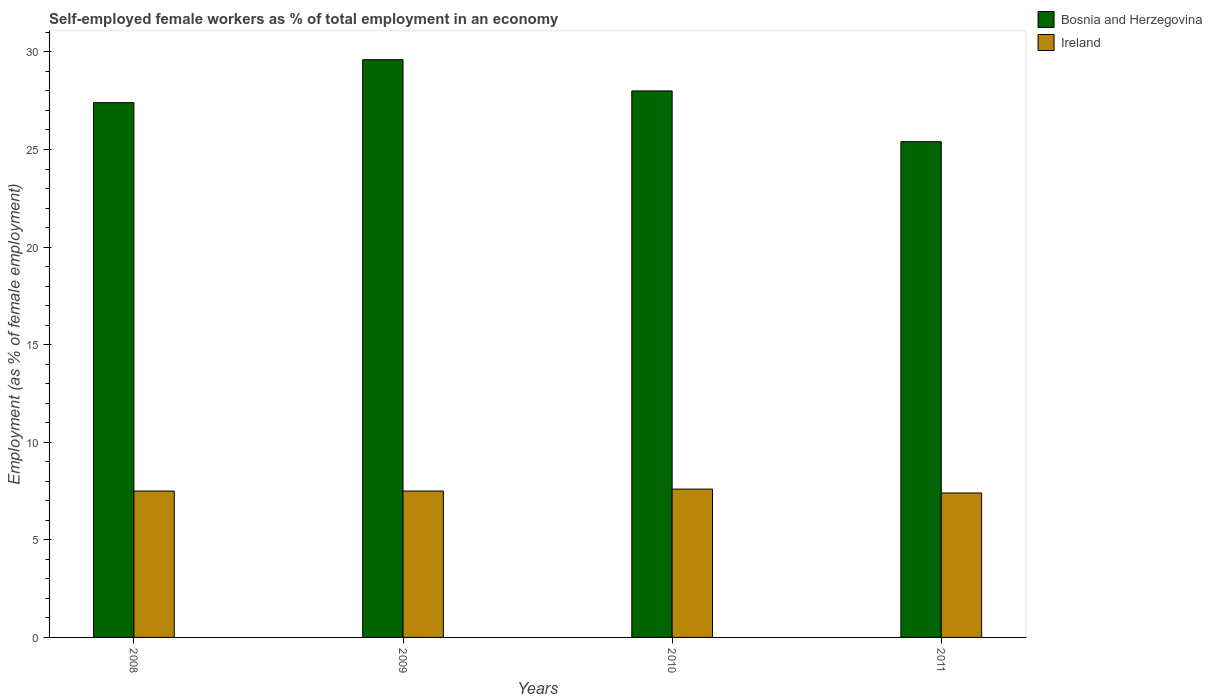How many different coloured bars are there?
Ensure brevity in your answer.  2. How many groups of bars are there?
Ensure brevity in your answer.  4. Are the number of bars per tick equal to the number of legend labels?
Provide a short and direct response. Yes. Are the number of bars on each tick of the X-axis equal?
Keep it short and to the point. Yes. How many bars are there on the 3rd tick from the left?
Offer a terse response. 2. In how many cases, is the number of bars for a given year not equal to the number of legend labels?
Ensure brevity in your answer.  0. What is the percentage of self-employed female workers in Ireland in 2009?
Make the answer very short. 7.5. Across all years, what is the maximum percentage of self-employed female workers in Ireland?
Give a very brief answer. 7.6. Across all years, what is the minimum percentage of self-employed female workers in Ireland?
Keep it short and to the point. 7.4. In which year was the percentage of self-employed female workers in Ireland minimum?
Give a very brief answer. 2011. What is the total percentage of self-employed female workers in Bosnia and Herzegovina in the graph?
Keep it short and to the point. 110.4. What is the difference between the percentage of self-employed female workers in Ireland in 2010 and that in 2011?
Ensure brevity in your answer.  0.2. What is the difference between the percentage of self-employed female workers in Bosnia and Herzegovina in 2008 and the percentage of self-employed female workers in Ireland in 2011?
Provide a short and direct response. 20. What is the average percentage of self-employed female workers in Ireland per year?
Provide a succinct answer. 7.5. In the year 2010, what is the difference between the percentage of self-employed female workers in Ireland and percentage of self-employed female workers in Bosnia and Herzegovina?
Make the answer very short. -20.4. In how many years, is the percentage of self-employed female workers in Bosnia and Herzegovina greater than 16 %?
Your answer should be compact. 4. What is the ratio of the percentage of self-employed female workers in Ireland in 2010 to that in 2011?
Make the answer very short. 1.03. Is the percentage of self-employed female workers in Bosnia and Herzegovina in 2008 less than that in 2011?
Offer a very short reply. No. What is the difference between the highest and the second highest percentage of self-employed female workers in Bosnia and Herzegovina?
Provide a succinct answer. 1.6. What is the difference between the highest and the lowest percentage of self-employed female workers in Bosnia and Herzegovina?
Ensure brevity in your answer.  4.2. Is the sum of the percentage of self-employed female workers in Ireland in 2008 and 2010 greater than the maximum percentage of self-employed female workers in Bosnia and Herzegovina across all years?
Provide a short and direct response. No. What does the 2nd bar from the left in 2011 represents?
Keep it short and to the point. Ireland. What does the 2nd bar from the right in 2008 represents?
Ensure brevity in your answer.  Bosnia and Herzegovina. Are all the bars in the graph horizontal?
Provide a succinct answer. No. How many years are there in the graph?
Offer a very short reply. 4. Does the graph contain any zero values?
Your answer should be compact. No. Where does the legend appear in the graph?
Your response must be concise. Top right. What is the title of the graph?
Provide a short and direct response. Self-employed female workers as % of total employment in an economy. What is the label or title of the Y-axis?
Provide a short and direct response. Employment (as % of female employment). What is the Employment (as % of female employment) in Bosnia and Herzegovina in 2008?
Keep it short and to the point. 27.4. What is the Employment (as % of female employment) in Ireland in 2008?
Offer a very short reply. 7.5. What is the Employment (as % of female employment) in Bosnia and Herzegovina in 2009?
Provide a succinct answer. 29.6. What is the Employment (as % of female employment) of Ireland in 2009?
Provide a short and direct response. 7.5. What is the Employment (as % of female employment) of Ireland in 2010?
Provide a succinct answer. 7.6. What is the Employment (as % of female employment) in Bosnia and Herzegovina in 2011?
Provide a succinct answer. 25.4. What is the Employment (as % of female employment) of Ireland in 2011?
Make the answer very short. 7.4. Across all years, what is the maximum Employment (as % of female employment) in Bosnia and Herzegovina?
Offer a terse response. 29.6. Across all years, what is the maximum Employment (as % of female employment) in Ireland?
Give a very brief answer. 7.6. Across all years, what is the minimum Employment (as % of female employment) in Bosnia and Herzegovina?
Ensure brevity in your answer.  25.4. Across all years, what is the minimum Employment (as % of female employment) of Ireland?
Give a very brief answer. 7.4. What is the total Employment (as % of female employment) in Bosnia and Herzegovina in the graph?
Your response must be concise. 110.4. What is the total Employment (as % of female employment) of Ireland in the graph?
Offer a terse response. 30. What is the difference between the Employment (as % of female employment) of Bosnia and Herzegovina in 2008 and that in 2009?
Your answer should be compact. -2.2. What is the difference between the Employment (as % of female employment) in Ireland in 2008 and that in 2009?
Provide a short and direct response. 0. What is the difference between the Employment (as % of female employment) of Bosnia and Herzegovina in 2008 and that in 2010?
Ensure brevity in your answer.  -0.6. What is the difference between the Employment (as % of female employment) in Ireland in 2008 and that in 2010?
Your answer should be compact. -0.1. What is the difference between the Employment (as % of female employment) of Bosnia and Herzegovina in 2008 and that in 2011?
Ensure brevity in your answer.  2. What is the difference between the Employment (as % of female employment) in Bosnia and Herzegovina in 2009 and that in 2010?
Your answer should be compact. 1.6. What is the difference between the Employment (as % of female employment) in Bosnia and Herzegovina in 2009 and that in 2011?
Your answer should be very brief. 4.2. What is the difference between the Employment (as % of female employment) of Bosnia and Herzegovina in 2010 and that in 2011?
Your response must be concise. 2.6. What is the difference between the Employment (as % of female employment) of Ireland in 2010 and that in 2011?
Provide a succinct answer. 0.2. What is the difference between the Employment (as % of female employment) of Bosnia and Herzegovina in 2008 and the Employment (as % of female employment) of Ireland in 2010?
Keep it short and to the point. 19.8. What is the difference between the Employment (as % of female employment) in Bosnia and Herzegovina in 2008 and the Employment (as % of female employment) in Ireland in 2011?
Provide a short and direct response. 20. What is the difference between the Employment (as % of female employment) in Bosnia and Herzegovina in 2009 and the Employment (as % of female employment) in Ireland in 2011?
Offer a terse response. 22.2. What is the difference between the Employment (as % of female employment) of Bosnia and Herzegovina in 2010 and the Employment (as % of female employment) of Ireland in 2011?
Ensure brevity in your answer.  20.6. What is the average Employment (as % of female employment) in Bosnia and Herzegovina per year?
Give a very brief answer. 27.6. What is the average Employment (as % of female employment) in Ireland per year?
Give a very brief answer. 7.5. In the year 2008, what is the difference between the Employment (as % of female employment) in Bosnia and Herzegovina and Employment (as % of female employment) in Ireland?
Your answer should be compact. 19.9. In the year 2009, what is the difference between the Employment (as % of female employment) of Bosnia and Herzegovina and Employment (as % of female employment) of Ireland?
Make the answer very short. 22.1. In the year 2010, what is the difference between the Employment (as % of female employment) of Bosnia and Herzegovina and Employment (as % of female employment) of Ireland?
Keep it short and to the point. 20.4. What is the ratio of the Employment (as % of female employment) in Bosnia and Herzegovina in 2008 to that in 2009?
Keep it short and to the point. 0.93. What is the ratio of the Employment (as % of female employment) in Bosnia and Herzegovina in 2008 to that in 2010?
Ensure brevity in your answer.  0.98. What is the ratio of the Employment (as % of female employment) of Bosnia and Herzegovina in 2008 to that in 2011?
Offer a terse response. 1.08. What is the ratio of the Employment (as % of female employment) in Ireland in 2008 to that in 2011?
Provide a succinct answer. 1.01. What is the ratio of the Employment (as % of female employment) in Bosnia and Herzegovina in 2009 to that in 2010?
Make the answer very short. 1.06. What is the ratio of the Employment (as % of female employment) in Bosnia and Herzegovina in 2009 to that in 2011?
Give a very brief answer. 1.17. What is the ratio of the Employment (as % of female employment) in Ireland in 2009 to that in 2011?
Provide a short and direct response. 1.01. What is the ratio of the Employment (as % of female employment) of Bosnia and Herzegovina in 2010 to that in 2011?
Your answer should be very brief. 1.1. What is the ratio of the Employment (as % of female employment) of Ireland in 2010 to that in 2011?
Your answer should be very brief. 1.03. What is the difference between the highest and the second highest Employment (as % of female employment) in Bosnia and Herzegovina?
Offer a very short reply. 1.6. 